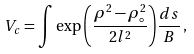Convert formula to latex. <formula><loc_0><loc_0><loc_500><loc_500>V _ { c } = \int \exp { \left ( \frac { \rho ^ { 2 } - \rho _ { \circ } ^ { 2 } } { 2 l ^ { 2 } } \right ) } \frac { d s } { B } \, ,</formula> 